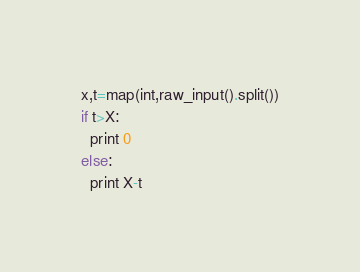<code> <loc_0><loc_0><loc_500><loc_500><_Python_>x,t=map(int,raw_input().split())
if t>X:
  print 0 
else:
  print X-t</code> 